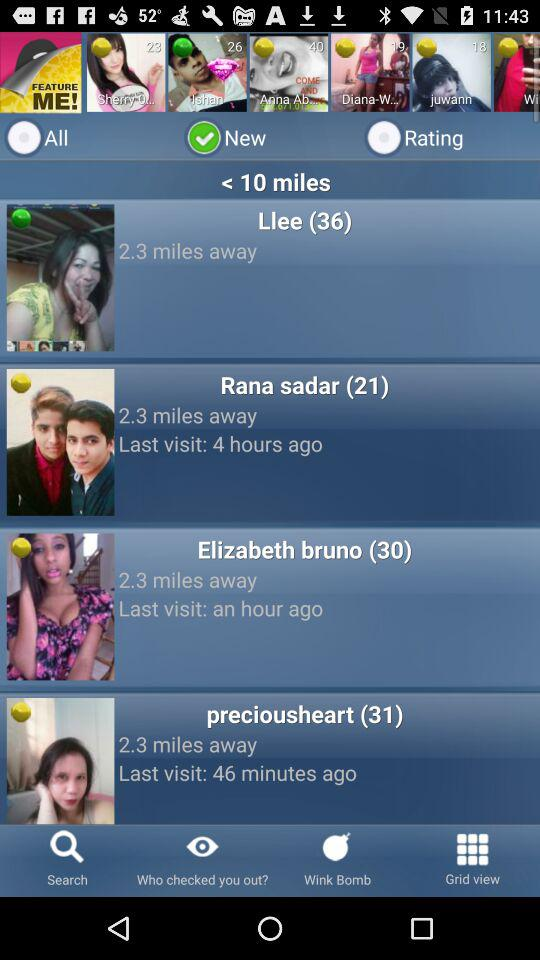When did Rana Sadar last visit? Rana Sadar last visited four hours ago. 